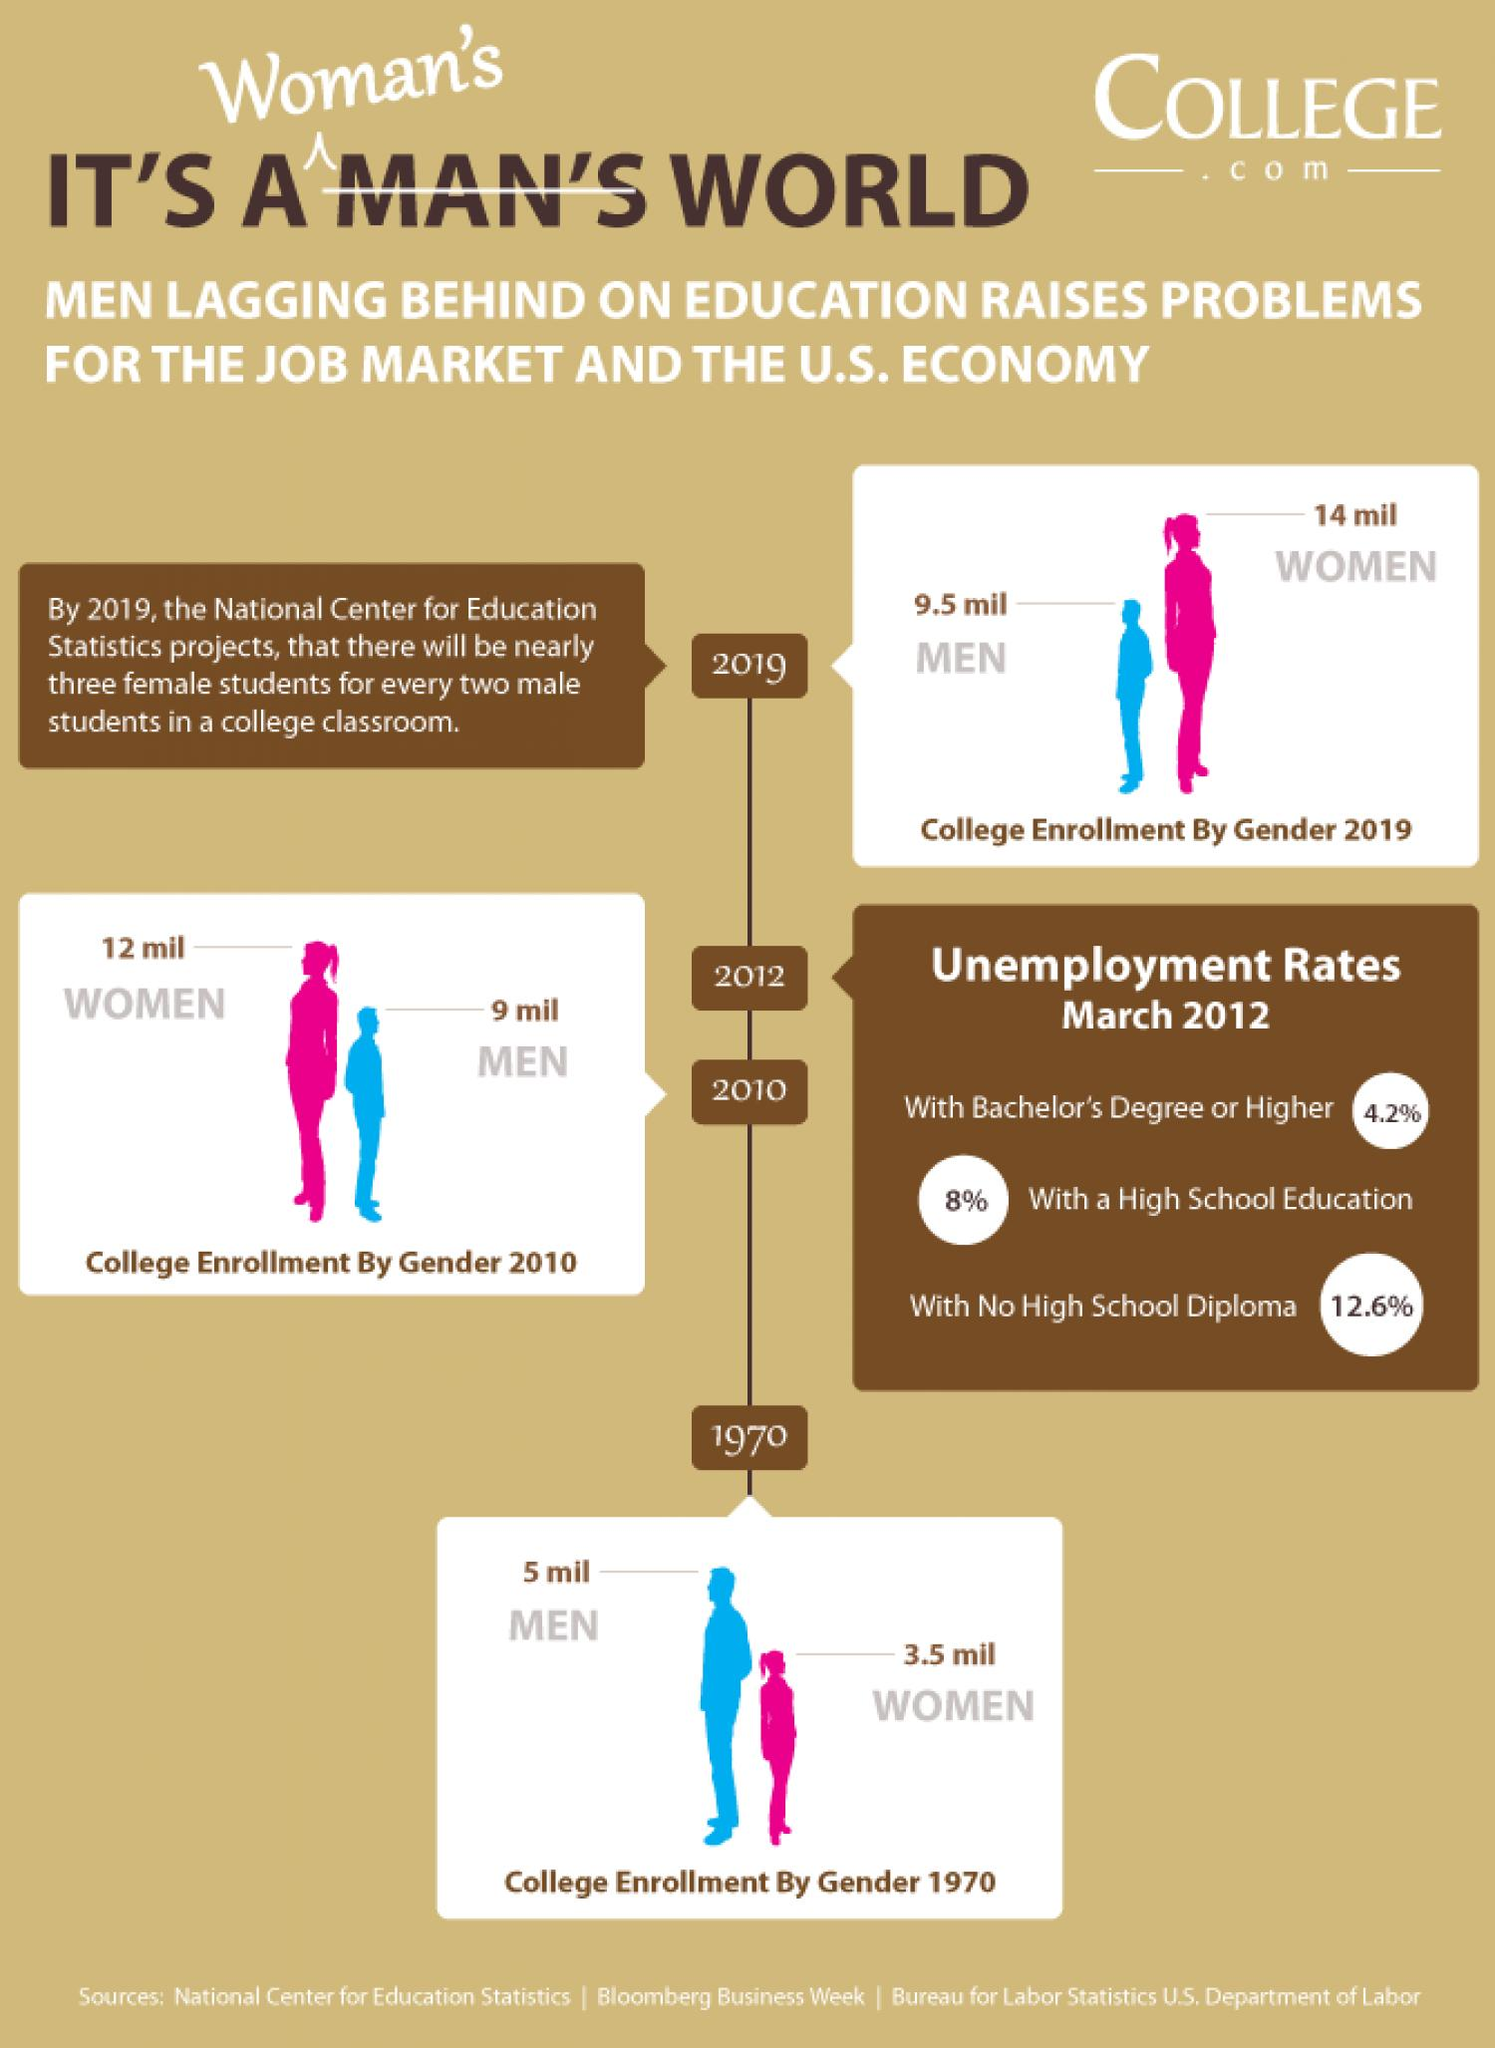Indicate a few pertinent items in this graphic. In 1970, there were 3.5 million fewer women enrolled than in 2019, which was a decrease of four times. The number of college enrollments for men increased by approximately 0.5 million from 2010 to 2019. 